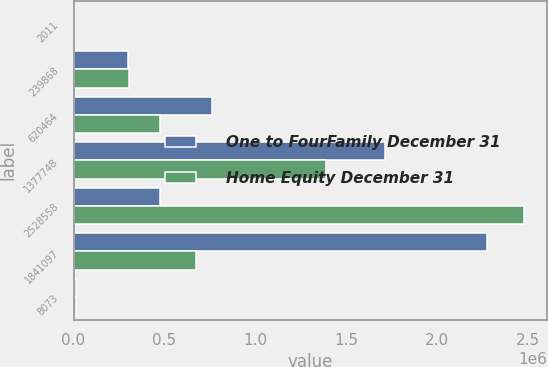Convert chart to OTSL. <chart><loc_0><loc_0><loc_500><loc_500><stacked_bar_chart><ecel><fcel>2011<fcel>239868<fcel>620464<fcel>1377748<fcel>2528558<fcel>1841097<fcel>8073<nl><fcel>One to FourFamily December 31<fcel>2010<fcel>297639<fcel>759307<fcel>1.7134e+06<fcel>472935<fcel>2.27663e+06<fcel>15071<nl><fcel>Home Equity December 31<fcel>2011<fcel>302606<fcel>472935<fcel>1.38704e+06<fcel>2.47997e+06<fcel>674742<fcel>11361<nl></chart> 